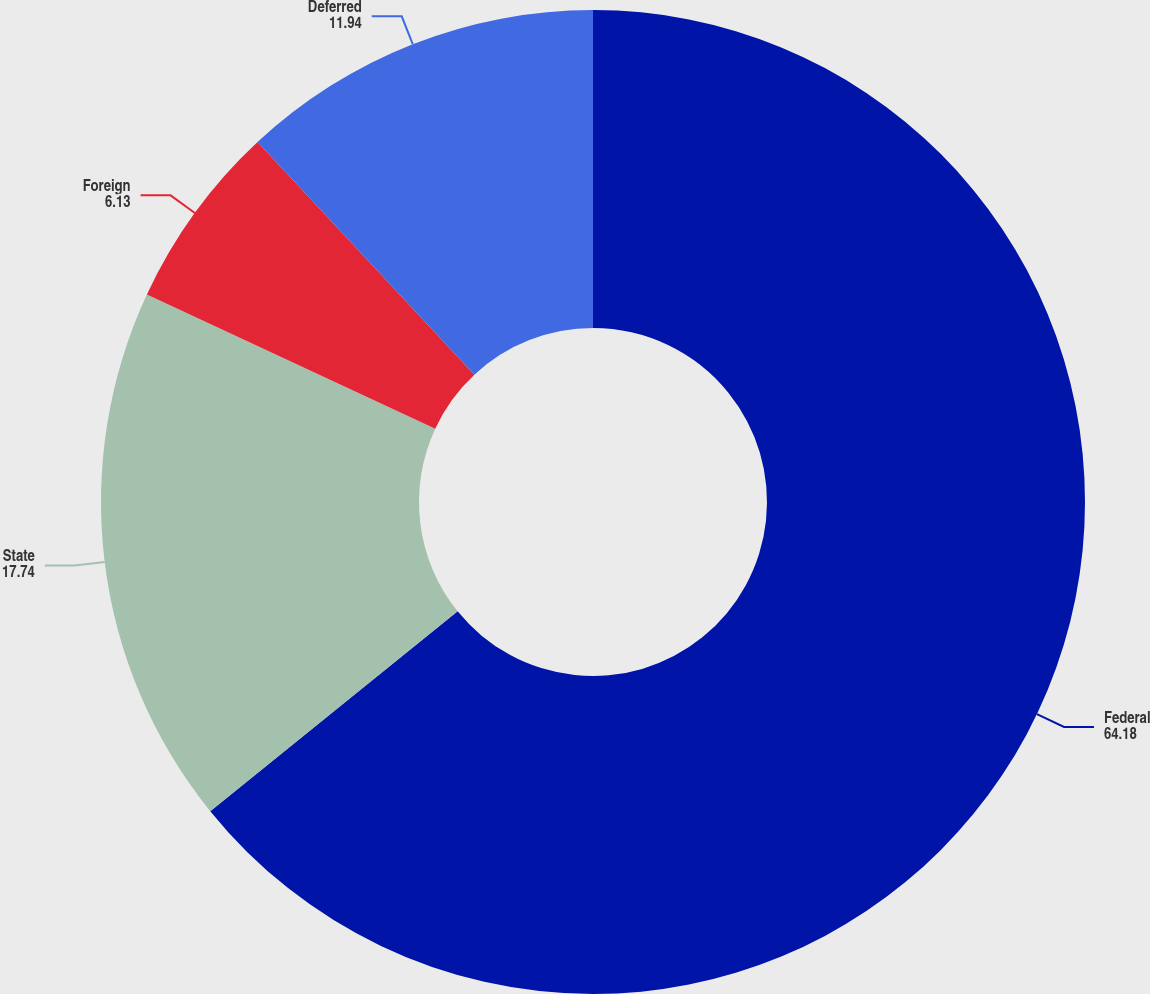<chart> <loc_0><loc_0><loc_500><loc_500><pie_chart><fcel>Federal<fcel>State<fcel>Foreign<fcel>Deferred<nl><fcel>64.18%<fcel>17.74%<fcel>6.13%<fcel>11.94%<nl></chart> 